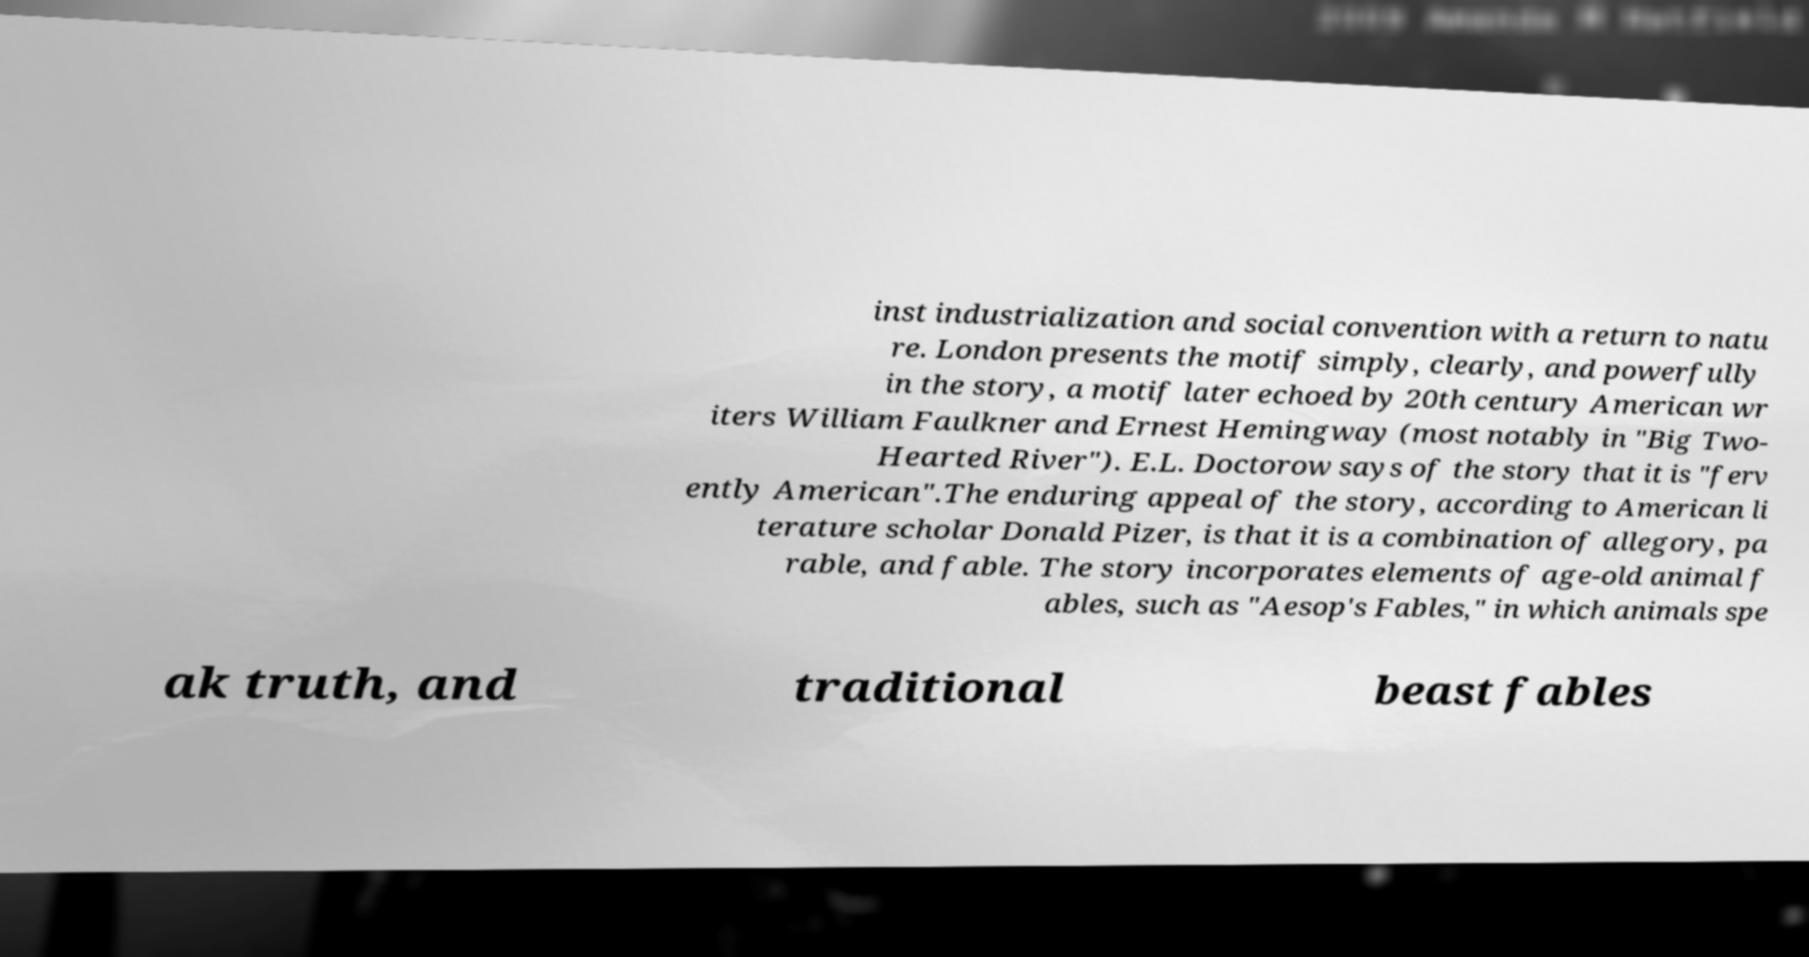Can you accurately transcribe the text from the provided image for me? inst industrialization and social convention with a return to natu re. London presents the motif simply, clearly, and powerfully in the story, a motif later echoed by 20th century American wr iters William Faulkner and Ernest Hemingway (most notably in "Big Two- Hearted River"). E.L. Doctorow says of the story that it is "ferv ently American".The enduring appeal of the story, according to American li terature scholar Donald Pizer, is that it is a combination of allegory, pa rable, and fable. The story incorporates elements of age-old animal f ables, such as "Aesop's Fables," in which animals spe ak truth, and traditional beast fables 